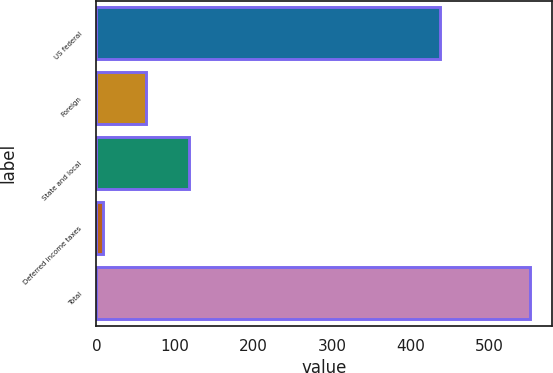Convert chart. <chart><loc_0><loc_0><loc_500><loc_500><bar_chart><fcel>US federal<fcel>Foreign<fcel>State and local<fcel>Deferred income taxes<fcel>Total<nl><fcel>437.3<fcel>63.34<fcel>117.58<fcel>9.1<fcel>551.5<nl></chart> 